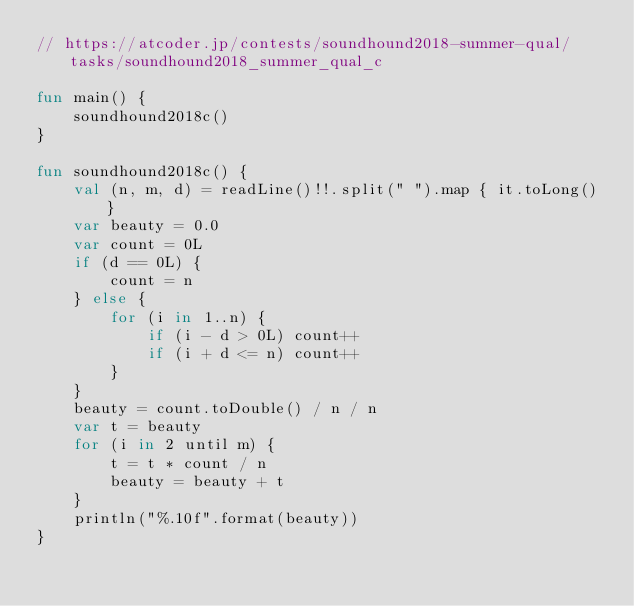<code> <loc_0><loc_0><loc_500><loc_500><_Kotlin_>// https://atcoder.jp/contests/soundhound2018-summer-qual/tasks/soundhound2018_summer_qual_c

fun main() {
    soundhound2018c()
}

fun soundhound2018c() {
    val (n, m, d) = readLine()!!.split(" ").map { it.toLong() }
    var beauty = 0.0
    var count = 0L
    if (d == 0L) {
        count = n
    } else {
        for (i in 1..n) {
            if (i - d > 0L) count++
            if (i + d <= n) count++
        }
    }
    beauty = count.toDouble() / n / n
    var t = beauty
    for (i in 2 until m) {
        t = t * count / n
        beauty = beauty + t
    }
    println("%.10f".format(beauty))
}</code> 